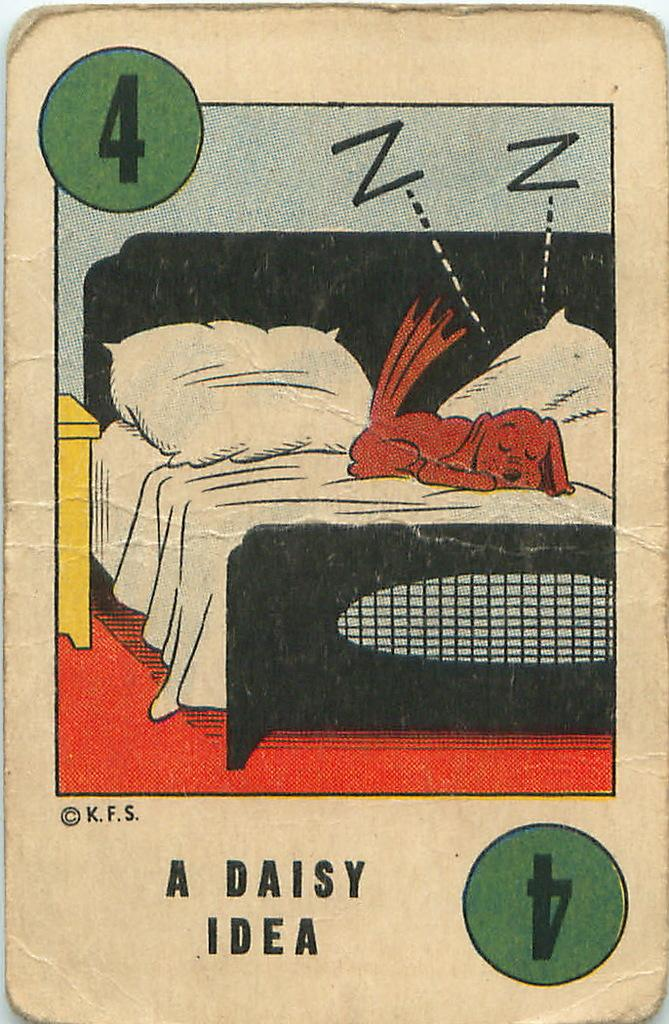What is the main subject of the image on the card? The main subject of the image is a dog sleeping on a bed. What can be seen in the background of the image? There are pillows visible in the image. Are there any additional elements on the card besides the image? Yes, there are numbers and letters on the card. What type of shirt is the dog wearing in the image? There is no shirt visible on the dog in the image; it is sleeping on a bed. Can you tell me how many buildings are in the image? There are no buildings present in the image; it features a dog sleeping on a bed. 